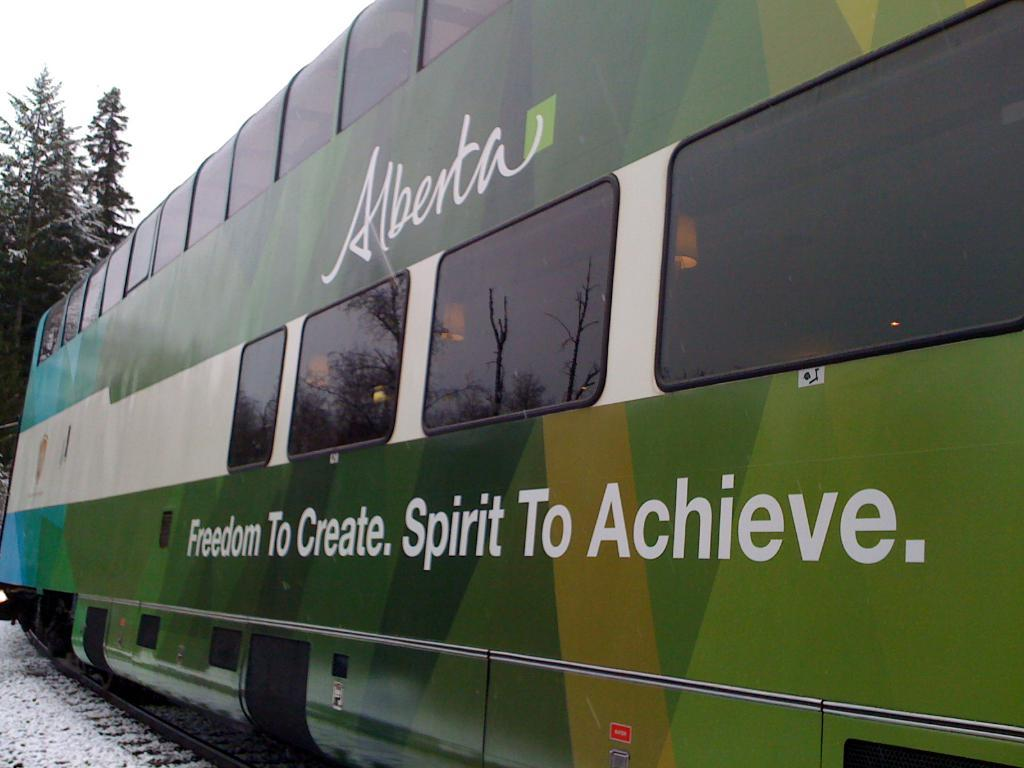What is the main subject in the foreground of the image? There is a train compartment in the foreground of the image. What is the train compartment's position in relation to the image? The train compartment is on a track. What is the weather like in the image? There is snow on the ground, indicating a cold or wintry weather. What can be seen in the background of the image? There is a tree and the sky visible in the background of the image. What are the kittens' opinions on the train compartment in the image? There are no kittens present in the image, so their opinions cannot be determined. 